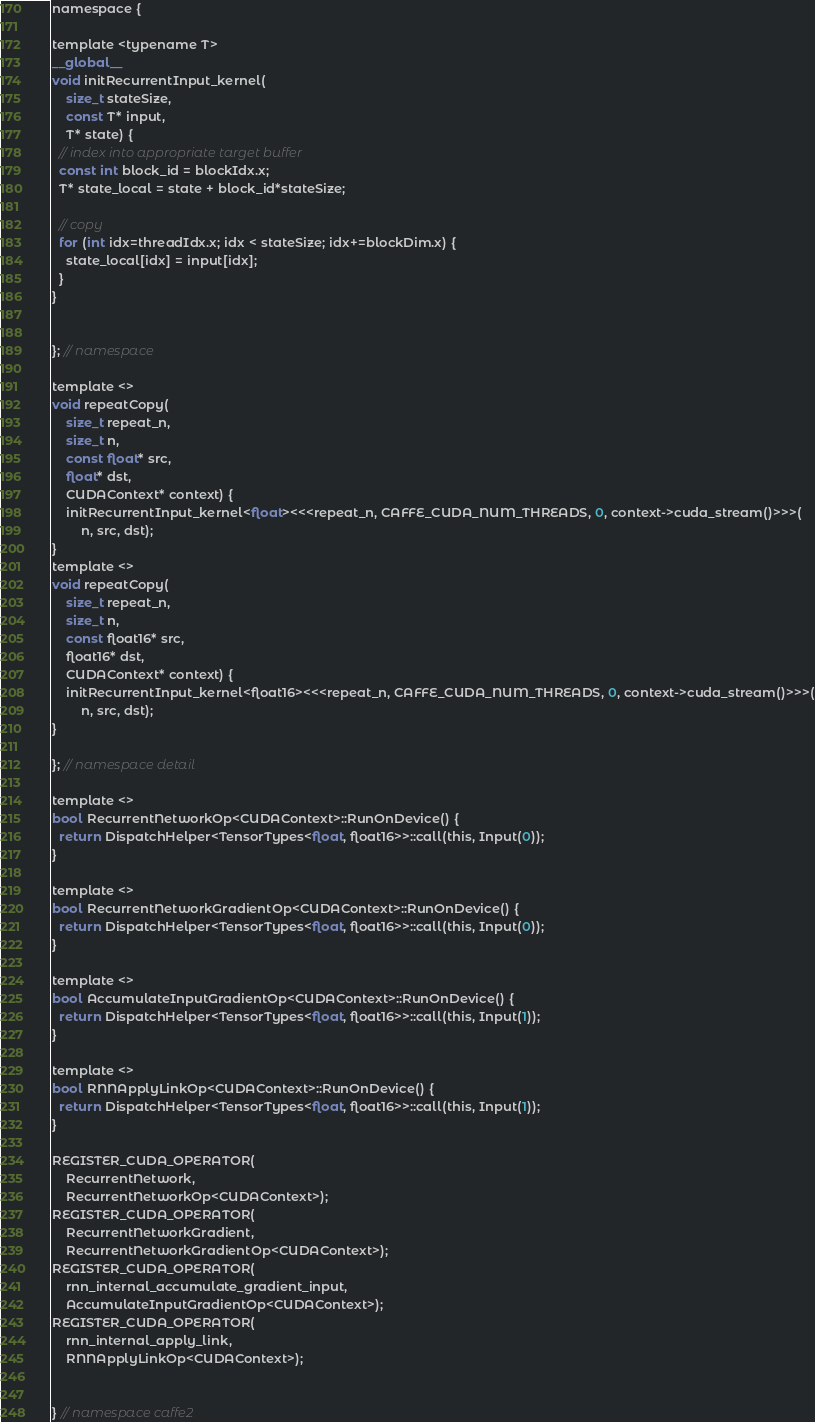Convert code to text. <code><loc_0><loc_0><loc_500><loc_500><_Cuda_>
namespace {

template <typename T>
__global__
void initRecurrentInput_kernel(
    size_t stateSize,
    const T* input,
    T* state) {
  // index into appropriate target buffer
  const int block_id = blockIdx.x;
  T* state_local = state + block_id*stateSize;

  // copy
  for (int idx=threadIdx.x; idx < stateSize; idx+=blockDim.x) {
    state_local[idx] = input[idx];
  }
}


}; // namespace

template <>
void repeatCopy(
    size_t repeat_n,
    size_t n,
    const float* src,
    float* dst,
    CUDAContext* context) {
    initRecurrentInput_kernel<float><<<repeat_n, CAFFE_CUDA_NUM_THREADS, 0, context->cuda_stream()>>>(
        n, src, dst);
}
template <>
void repeatCopy(
    size_t repeat_n,
    size_t n,
    const float16* src,
    float16* dst,
    CUDAContext* context) {
    initRecurrentInput_kernel<float16><<<repeat_n, CAFFE_CUDA_NUM_THREADS, 0, context->cuda_stream()>>>(
        n, src, dst);
}

}; // namespace detail

template <>
bool RecurrentNetworkOp<CUDAContext>::RunOnDevice() {
  return DispatchHelper<TensorTypes<float, float16>>::call(this, Input(0));
}

template <>
bool RecurrentNetworkGradientOp<CUDAContext>::RunOnDevice() {
  return DispatchHelper<TensorTypes<float, float16>>::call(this, Input(0));
}

template <>
bool AccumulateInputGradientOp<CUDAContext>::RunOnDevice() {
  return DispatchHelper<TensorTypes<float, float16>>::call(this, Input(1));
}

template <>
bool RNNApplyLinkOp<CUDAContext>::RunOnDevice() {
  return DispatchHelper<TensorTypes<float, float16>>::call(this, Input(1));
}

REGISTER_CUDA_OPERATOR(
    RecurrentNetwork,
    RecurrentNetworkOp<CUDAContext>);
REGISTER_CUDA_OPERATOR(
    RecurrentNetworkGradient,
    RecurrentNetworkGradientOp<CUDAContext>);
REGISTER_CUDA_OPERATOR(
    rnn_internal_accumulate_gradient_input,
    AccumulateInputGradientOp<CUDAContext>);
REGISTER_CUDA_OPERATOR(
    rnn_internal_apply_link,
    RNNApplyLinkOp<CUDAContext>);


} // namespace caffe2
</code> 